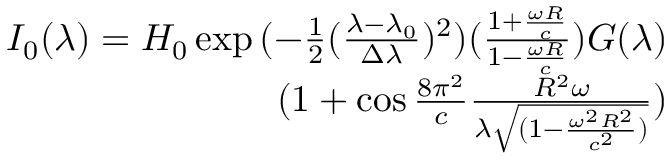<formula> <loc_0><loc_0><loc_500><loc_500>\begin{array} { r } { I _ { 0 } ( \lambda ) = H _ { 0 } \exp { ( - \frac { 1 } { 2 } ( \frac { \lambda - \lambda _ { 0 } } { \Delta \lambda } ) ^ { 2 } ) ( \frac { 1 + \frac { \omega R } { c } } { 1 - \frac { \omega R } { c } } ) } G ( \lambda ) } \\ { ( 1 + \cos { \frac { 8 \pi ^ { 2 } } { c } \frac { R ^ { 2 } \omega } { \lambda \sqrt { ( 1 - \frac { \omega ^ { 2 } R ^ { 2 } } { c ^ { 2 } } ) } } } ) } \end{array}</formula> 